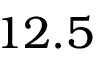Convert formula to latex. <formula><loc_0><loc_0><loc_500><loc_500>1 2 . 5</formula> 